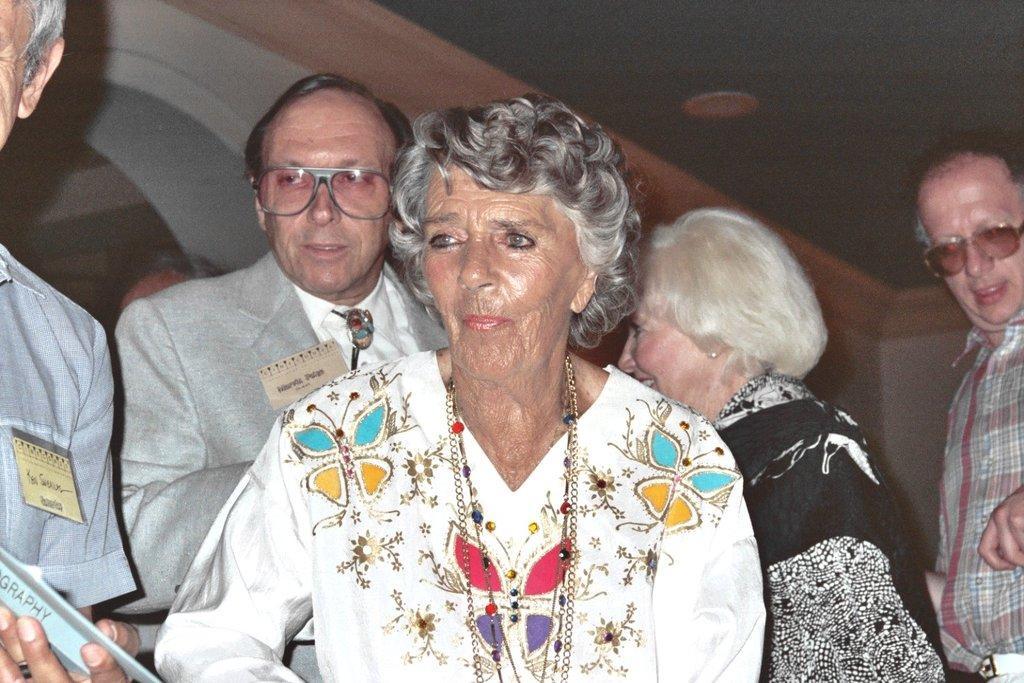Could you give a brief overview of what you see in this image? There are people and this person holding a book. In the background we can see wall. 